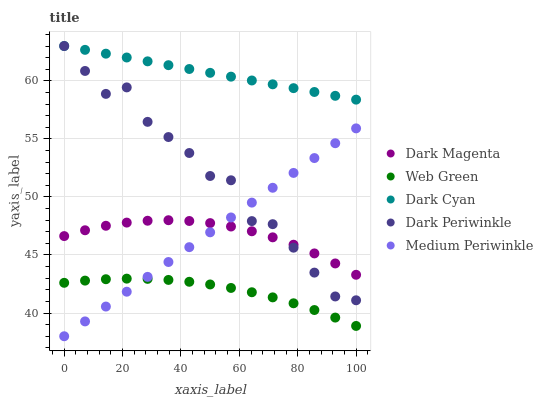Does Web Green have the minimum area under the curve?
Answer yes or no. Yes. Does Dark Cyan have the maximum area under the curve?
Answer yes or no. Yes. Does Medium Periwinkle have the minimum area under the curve?
Answer yes or no. No. Does Medium Periwinkle have the maximum area under the curve?
Answer yes or no. No. Is Dark Cyan the smoothest?
Answer yes or no. Yes. Is Dark Periwinkle the roughest?
Answer yes or no. Yes. Is Medium Periwinkle the smoothest?
Answer yes or no. No. Is Medium Periwinkle the roughest?
Answer yes or no. No. Does Medium Periwinkle have the lowest value?
Answer yes or no. Yes. Does Dark Magenta have the lowest value?
Answer yes or no. No. Does Dark Periwinkle have the highest value?
Answer yes or no. Yes. Does Medium Periwinkle have the highest value?
Answer yes or no. No. Is Web Green less than Dark Periwinkle?
Answer yes or no. Yes. Is Dark Periwinkle greater than Web Green?
Answer yes or no. Yes. Does Dark Cyan intersect Dark Periwinkle?
Answer yes or no. Yes. Is Dark Cyan less than Dark Periwinkle?
Answer yes or no. No. Is Dark Cyan greater than Dark Periwinkle?
Answer yes or no. No. Does Web Green intersect Dark Periwinkle?
Answer yes or no. No. 